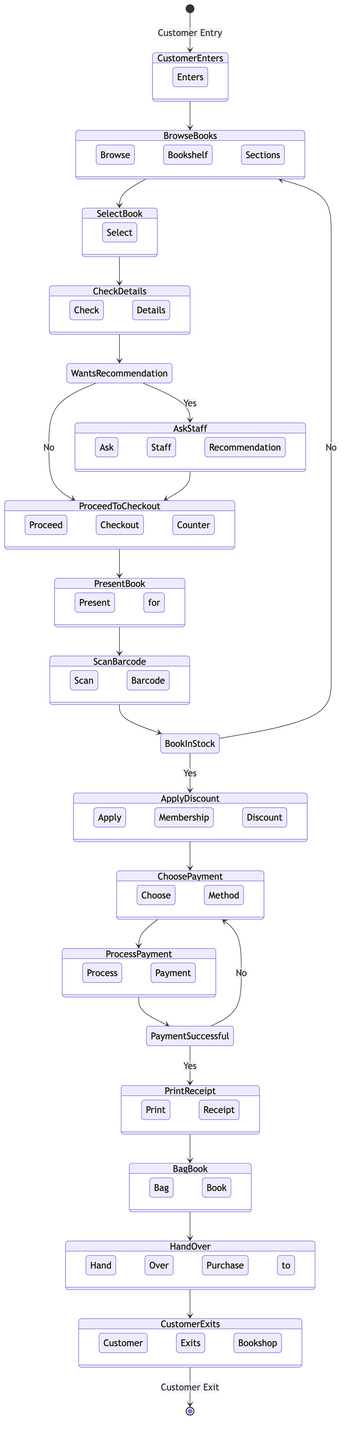What is the starting event of the diagram? The diagram begins with the event "Customer Entry," which indicates the initial action taken by the customer as they enter the bookshop.
Answer: Customer Entry How many decisions are present in the diagram? The diagram features three decision points that determine the flow of activities based on customer choices, specifically regarding recommendations, stock status, and payment success.
Answer: 3 What activity follows after the customer selects a book? After selecting a book, the next activity is "Check Book Details," where customers verify the specifics of the book they are interested in.
Answer: Check Book Details What happens if the book is not in stock? If the book is not in stock, the flow leads back to "Browse Bookshelf Sections," allowing the customer to look for another book instead of proceeding to checkout.
Answer: Browse Bookshelf Sections What is the final activity in the checkout process? The last activity in the diagram is "Customer Exits Bookshop," which signifies that the purchase process is complete, and the customer leaves the shop.
Answer: Customer Exits Bookshop What choice is made if the customer asks for a recommendation? If the customer wants a recommendation, they will "Ask Staff for Recommendation," which is a positive choice that leads them to ask for guidance from the staff.
Answer: Ask Staff for Recommendation What activity occurs after the payment is processed? After the payment is successfully processed, the next activity is "Print Receipt," which involves generating a receipt for the customer to confirm their purchase.
Answer: Print Receipt How many activities take place after scanning the book barcode? After scanning the book barcode, there are two activities available: applying the membership discount (if applicable) and choosing the payment method, leading to a total of two.
Answer: 2 What is the decision made after the payment process if it is unsuccessful? If the payment is unsuccessful, the process loops back to "Choose Payment Method," allowing customers to select an alternative payment option instead of proceeding further.
Answer: Choose Payment Method 